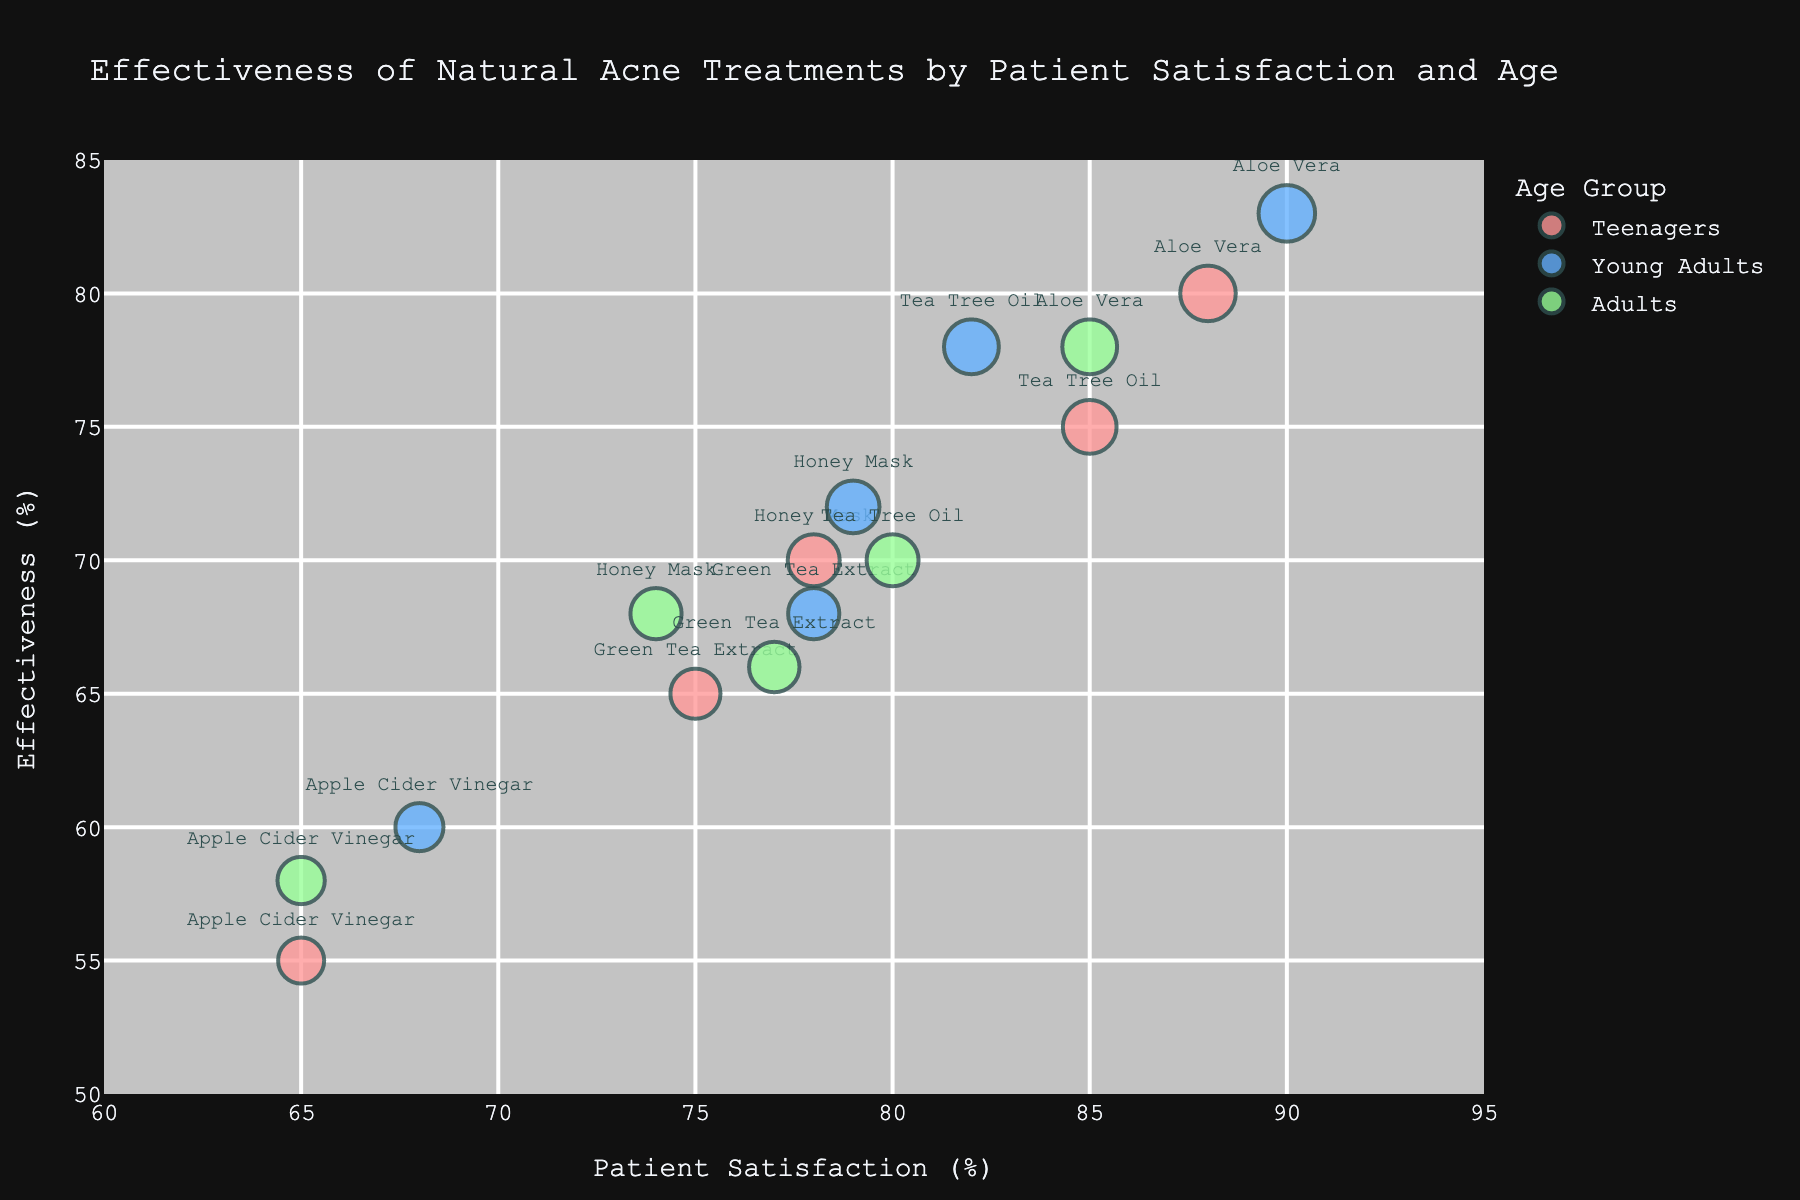What is the title of the figure? The title of the figure is often displayed at the top and provides an overview of what the chart is about. By looking at the top, you can see the title.
Answer: Effectiveness of Natural Acne Treatments by Patient Satisfaction and Age How many treatments are evaluated in the chart? By examining the different text labels on the bubbles, you can count the distinct treatments listed. There are four treatments: Tea Tree Oil, Green Tea Extract, Aloe Vera, Honey Mask, and Apple Cider Vinegar.
Answer: Five Which treatment for Young Adults has the highest patient satisfaction? Locate the bubbles for "Young Adults" by their color and identify the one with the highest position on the Patient Satisfaction axis.
Answer: Aloe Vera What color is used to represent the Teenagers age group? Based on the color map used in the chart, identify the color repeatedly associated with the "Teenagers" age group.
Answer: Light Red Which age group has the highest effectiveness for Tea Tree Oil? Look at the bubbles labeled "Tea Tree Oil" and identify the one with the highest position on the Effectiveness axis; then check the age group from the color.
Answer: Young Adults How does the patient satisfaction for Green Tea Extract compare between Teenagers and Adults? Compare the positions of the Green Tea Extract bubbles on the Patient Satisfaction axis for Teenagers and Adults.
Answer: Teenagers: 75, Adults: 77. Teenagers have slightly lower satisfaction than Adults Which treatment has the lowest effectiveness for Teenagers? Identify the bubbles for the "Teenagers" age group and find the one with the lowest position on the Effectiveness axis.
Answer: Apple Cider Vinegar Is there any treatment where patient satisfaction decreases with age? Examine the Patient Satisfaction axis for each treatment bubble across different age groups and note any downward trend.
Answer: Tea Tree Oil (Teenagers: 85, Young Adults: 82, Adults: 80) How many treatments have a patient satisfaction of 80% or higher for Young Adults? Identify the bubbles in the "Young Adults" age group and count those with positions on the Patient Satisfaction axis at or above 80%.
Answer: Two (Aloe Vera and Tea Tree Oil) 